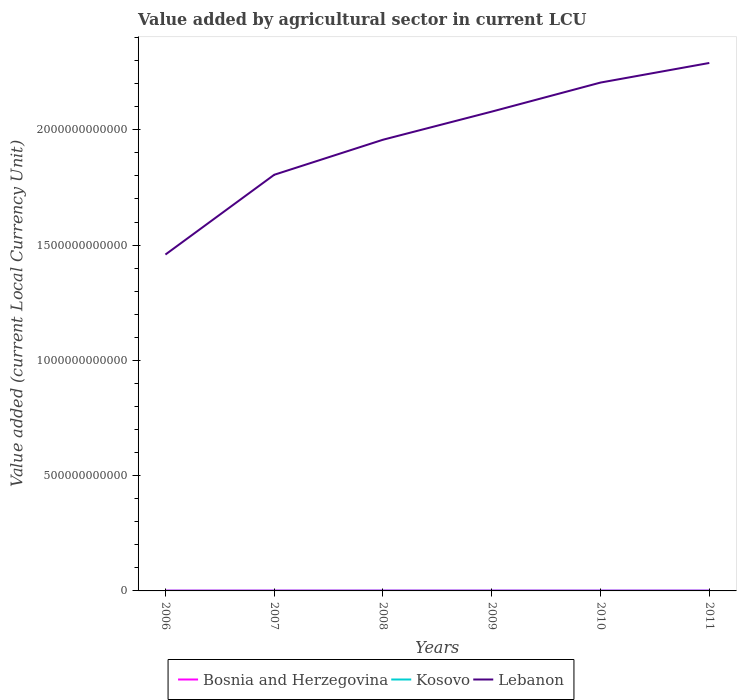Is the number of lines equal to the number of legend labels?
Keep it short and to the point. Yes. Across all years, what is the maximum value added by agricultural sector in Lebanon?
Give a very brief answer. 1.46e+12. What is the total value added by agricultural sector in Bosnia and Herzegovina in the graph?
Ensure brevity in your answer.  -1.02e+08. What is the difference between the highest and the second highest value added by agricultural sector in Lebanon?
Your answer should be very brief. 8.31e+11. What is the difference between the highest and the lowest value added by agricultural sector in Kosovo?
Offer a terse response. 4. How many years are there in the graph?
Your answer should be compact. 6. What is the difference between two consecutive major ticks on the Y-axis?
Offer a terse response. 5.00e+11. Are the values on the major ticks of Y-axis written in scientific E-notation?
Offer a very short reply. No. How many legend labels are there?
Give a very brief answer. 3. How are the legend labels stacked?
Your answer should be very brief. Horizontal. What is the title of the graph?
Give a very brief answer. Value added by agricultural sector in current LCU. Does "San Marino" appear as one of the legend labels in the graph?
Your answer should be compact. No. What is the label or title of the Y-axis?
Ensure brevity in your answer.  Value added (current Local Currency Unit). What is the Value added (current Local Currency Unit) in Bosnia and Herzegovina in 2006?
Offer a very short reply. 1.61e+09. What is the Value added (current Local Currency Unit) of Kosovo in 2006?
Offer a terse response. 3.72e+08. What is the Value added (current Local Currency Unit) of Lebanon in 2006?
Provide a short and direct response. 1.46e+12. What is the Value added (current Local Currency Unit) of Bosnia and Herzegovina in 2007?
Offer a very short reply. 1.73e+09. What is the Value added (current Local Currency Unit) of Kosovo in 2007?
Your response must be concise. 4.79e+08. What is the Value added (current Local Currency Unit) of Lebanon in 2007?
Your answer should be very brief. 1.80e+12. What is the Value added (current Local Currency Unit) in Bosnia and Herzegovina in 2008?
Provide a short and direct response. 1.83e+09. What is the Value added (current Local Currency Unit) in Kosovo in 2008?
Offer a very short reply. 5.74e+08. What is the Value added (current Local Currency Unit) of Lebanon in 2008?
Offer a terse response. 1.96e+12. What is the Value added (current Local Currency Unit) in Bosnia and Herzegovina in 2009?
Make the answer very short. 1.75e+09. What is the Value added (current Local Currency Unit) in Kosovo in 2009?
Provide a succinct answer. 5.75e+08. What is the Value added (current Local Currency Unit) of Lebanon in 2009?
Your response must be concise. 2.08e+12. What is the Value added (current Local Currency Unit) in Bosnia and Herzegovina in 2010?
Your answer should be very brief. 1.72e+09. What is the Value added (current Local Currency Unit) of Kosovo in 2010?
Make the answer very short. 5.99e+08. What is the Value added (current Local Currency Unit) in Lebanon in 2010?
Keep it short and to the point. 2.20e+12. What is the Value added (current Local Currency Unit) in Bosnia and Herzegovina in 2011?
Offer a terse response. 1.77e+09. What is the Value added (current Local Currency Unit) of Kosovo in 2011?
Offer a very short reply. 6.14e+08. What is the Value added (current Local Currency Unit) in Lebanon in 2011?
Give a very brief answer. 2.29e+12. Across all years, what is the maximum Value added (current Local Currency Unit) of Bosnia and Herzegovina?
Ensure brevity in your answer.  1.83e+09. Across all years, what is the maximum Value added (current Local Currency Unit) in Kosovo?
Provide a succinct answer. 6.14e+08. Across all years, what is the maximum Value added (current Local Currency Unit) of Lebanon?
Give a very brief answer. 2.29e+12. Across all years, what is the minimum Value added (current Local Currency Unit) in Bosnia and Herzegovina?
Your answer should be compact. 1.61e+09. Across all years, what is the minimum Value added (current Local Currency Unit) of Kosovo?
Your answer should be compact. 3.72e+08. Across all years, what is the minimum Value added (current Local Currency Unit) of Lebanon?
Your response must be concise. 1.46e+12. What is the total Value added (current Local Currency Unit) of Bosnia and Herzegovina in the graph?
Your answer should be compact. 1.04e+1. What is the total Value added (current Local Currency Unit) of Kosovo in the graph?
Keep it short and to the point. 3.21e+09. What is the total Value added (current Local Currency Unit) of Lebanon in the graph?
Your response must be concise. 1.18e+13. What is the difference between the Value added (current Local Currency Unit) of Bosnia and Herzegovina in 2006 and that in 2007?
Your answer should be compact. -1.23e+08. What is the difference between the Value added (current Local Currency Unit) of Kosovo in 2006 and that in 2007?
Offer a very short reply. -1.06e+08. What is the difference between the Value added (current Local Currency Unit) in Lebanon in 2006 and that in 2007?
Make the answer very short. -3.46e+11. What is the difference between the Value added (current Local Currency Unit) of Bosnia and Herzegovina in 2006 and that in 2008?
Your answer should be very brief. -2.25e+08. What is the difference between the Value added (current Local Currency Unit) in Kosovo in 2006 and that in 2008?
Provide a succinct answer. -2.02e+08. What is the difference between the Value added (current Local Currency Unit) of Lebanon in 2006 and that in 2008?
Provide a succinct answer. -4.98e+11. What is the difference between the Value added (current Local Currency Unit) in Bosnia and Herzegovina in 2006 and that in 2009?
Keep it short and to the point. -1.38e+08. What is the difference between the Value added (current Local Currency Unit) in Kosovo in 2006 and that in 2009?
Offer a very short reply. -2.03e+08. What is the difference between the Value added (current Local Currency Unit) in Lebanon in 2006 and that in 2009?
Provide a succinct answer. -6.20e+11. What is the difference between the Value added (current Local Currency Unit) in Bosnia and Herzegovina in 2006 and that in 2010?
Offer a terse response. -1.07e+08. What is the difference between the Value added (current Local Currency Unit) in Kosovo in 2006 and that in 2010?
Keep it short and to the point. -2.26e+08. What is the difference between the Value added (current Local Currency Unit) in Lebanon in 2006 and that in 2010?
Offer a terse response. -7.46e+11. What is the difference between the Value added (current Local Currency Unit) of Bosnia and Herzegovina in 2006 and that in 2011?
Provide a succinct answer. -1.58e+08. What is the difference between the Value added (current Local Currency Unit) of Kosovo in 2006 and that in 2011?
Provide a short and direct response. -2.42e+08. What is the difference between the Value added (current Local Currency Unit) of Lebanon in 2006 and that in 2011?
Provide a succinct answer. -8.31e+11. What is the difference between the Value added (current Local Currency Unit) of Bosnia and Herzegovina in 2007 and that in 2008?
Provide a short and direct response. -1.02e+08. What is the difference between the Value added (current Local Currency Unit) in Kosovo in 2007 and that in 2008?
Your answer should be compact. -9.56e+07. What is the difference between the Value added (current Local Currency Unit) in Lebanon in 2007 and that in 2008?
Offer a very short reply. -1.52e+11. What is the difference between the Value added (current Local Currency Unit) in Bosnia and Herzegovina in 2007 and that in 2009?
Offer a very short reply. -1.56e+07. What is the difference between the Value added (current Local Currency Unit) of Kosovo in 2007 and that in 2009?
Offer a very short reply. -9.64e+07. What is the difference between the Value added (current Local Currency Unit) in Lebanon in 2007 and that in 2009?
Your response must be concise. -2.74e+11. What is the difference between the Value added (current Local Currency Unit) of Bosnia and Herzegovina in 2007 and that in 2010?
Your answer should be compact. 1.55e+07. What is the difference between the Value added (current Local Currency Unit) of Kosovo in 2007 and that in 2010?
Your response must be concise. -1.20e+08. What is the difference between the Value added (current Local Currency Unit) in Lebanon in 2007 and that in 2010?
Make the answer very short. -4.00e+11. What is the difference between the Value added (current Local Currency Unit) of Bosnia and Herzegovina in 2007 and that in 2011?
Provide a short and direct response. -3.57e+07. What is the difference between the Value added (current Local Currency Unit) in Kosovo in 2007 and that in 2011?
Your answer should be compact. -1.36e+08. What is the difference between the Value added (current Local Currency Unit) in Lebanon in 2007 and that in 2011?
Give a very brief answer. -4.85e+11. What is the difference between the Value added (current Local Currency Unit) of Bosnia and Herzegovina in 2008 and that in 2009?
Your response must be concise. 8.65e+07. What is the difference between the Value added (current Local Currency Unit) in Kosovo in 2008 and that in 2009?
Provide a short and direct response. -8.00e+05. What is the difference between the Value added (current Local Currency Unit) in Lebanon in 2008 and that in 2009?
Offer a very short reply. -1.22e+11. What is the difference between the Value added (current Local Currency Unit) of Bosnia and Herzegovina in 2008 and that in 2010?
Make the answer very short. 1.18e+08. What is the difference between the Value added (current Local Currency Unit) in Kosovo in 2008 and that in 2010?
Give a very brief answer. -2.44e+07. What is the difference between the Value added (current Local Currency Unit) of Lebanon in 2008 and that in 2010?
Ensure brevity in your answer.  -2.48e+11. What is the difference between the Value added (current Local Currency Unit) in Bosnia and Herzegovina in 2008 and that in 2011?
Your answer should be compact. 6.64e+07. What is the difference between the Value added (current Local Currency Unit) of Kosovo in 2008 and that in 2011?
Keep it short and to the point. -3.99e+07. What is the difference between the Value added (current Local Currency Unit) in Lebanon in 2008 and that in 2011?
Give a very brief answer. -3.33e+11. What is the difference between the Value added (current Local Currency Unit) of Bosnia and Herzegovina in 2009 and that in 2010?
Offer a very short reply. 3.11e+07. What is the difference between the Value added (current Local Currency Unit) of Kosovo in 2009 and that in 2010?
Keep it short and to the point. -2.36e+07. What is the difference between the Value added (current Local Currency Unit) of Lebanon in 2009 and that in 2010?
Ensure brevity in your answer.  -1.26e+11. What is the difference between the Value added (current Local Currency Unit) of Bosnia and Herzegovina in 2009 and that in 2011?
Give a very brief answer. -2.01e+07. What is the difference between the Value added (current Local Currency Unit) in Kosovo in 2009 and that in 2011?
Offer a very short reply. -3.91e+07. What is the difference between the Value added (current Local Currency Unit) of Lebanon in 2009 and that in 2011?
Make the answer very short. -2.11e+11. What is the difference between the Value added (current Local Currency Unit) in Bosnia and Herzegovina in 2010 and that in 2011?
Ensure brevity in your answer.  -5.12e+07. What is the difference between the Value added (current Local Currency Unit) in Kosovo in 2010 and that in 2011?
Provide a short and direct response. -1.55e+07. What is the difference between the Value added (current Local Currency Unit) in Lebanon in 2010 and that in 2011?
Keep it short and to the point. -8.50e+1. What is the difference between the Value added (current Local Currency Unit) of Bosnia and Herzegovina in 2006 and the Value added (current Local Currency Unit) of Kosovo in 2007?
Provide a short and direct response. 1.13e+09. What is the difference between the Value added (current Local Currency Unit) of Bosnia and Herzegovina in 2006 and the Value added (current Local Currency Unit) of Lebanon in 2007?
Keep it short and to the point. -1.80e+12. What is the difference between the Value added (current Local Currency Unit) of Kosovo in 2006 and the Value added (current Local Currency Unit) of Lebanon in 2007?
Your response must be concise. -1.80e+12. What is the difference between the Value added (current Local Currency Unit) of Bosnia and Herzegovina in 2006 and the Value added (current Local Currency Unit) of Kosovo in 2008?
Make the answer very short. 1.04e+09. What is the difference between the Value added (current Local Currency Unit) in Bosnia and Herzegovina in 2006 and the Value added (current Local Currency Unit) in Lebanon in 2008?
Provide a succinct answer. -1.96e+12. What is the difference between the Value added (current Local Currency Unit) in Kosovo in 2006 and the Value added (current Local Currency Unit) in Lebanon in 2008?
Ensure brevity in your answer.  -1.96e+12. What is the difference between the Value added (current Local Currency Unit) in Bosnia and Herzegovina in 2006 and the Value added (current Local Currency Unit) in Kosovo in 2009?
Give a very brief answer. 1.03e+09. What is the difference between the Value added (current Local Currency Unit) of Bosnia and Herzegovina in 2006 and the Value added (current Local Currency Unit) of Lebanon in 2009?
Offer a terse response. -2.08e+12. What is the difference between the Value added (current Local Currency Unit) of Kosovo in 2006 and the Value added (current Local Currency Unit) of Lebanon in 2009?
Your answer should be compact. -2.08e+12. What is the difference between the Value added (current Local Currency Unit) in Bosnia and Herzegovina in 2006 and the Value added (current Local Currency Unit) in Kosovo in 2010?
Ensure brevity in your answer.  1.01e+09. What is the difference between the Value added (current Local Currency Unit) in Bosnia and Herzegovina in 2006 and the Value added (current Local Currency Unit) in Lebanon in 2010?
Make the answer very short. -2.20e+12. What is the difference between the Value added (current Local Currency Unit) of Kosovo in 2006 and the Value added (current Local Currency Unit) of Lebanon in 2010?
Your answer should be compact. -2.20e+12. What is the difference between the Value added (current Local Currency Unit) in Bosnia and Herzegovina in 2006 and the Value added (current Local Currency Unit) in Kosovo in 2011?
Your response must be concise. 9.96e+08. What is the difference between the Value added (current Local Currency Unit) in Bosnia and Herzegovina in 2006 and the Value added (current Local Currency Unit) in Lebanon in 2011?
Offer a terse response. -2.29e+12. What is the difference between the Value added (current Local Currency Unit) in Kosovo in 2006 and the Value added (current Local Currency Unit) in Lebanon in 2011?
Your answer should be very brief. -2.29e+12. What is the difference between the Value added (current Local Currency Unit) in Bosnia and Herzegovina in 2007 and the Value added (current Local Currency Unit) in Kosovo in 2008?
Your answer should be very brief. 1.16e+09. What is the difference between the Value added (current Local Currency Unit) of Bosnia and Herzegovina in 2007 and the Value added (current Local Currency Unit) of Lebanon in 2008?
Offer a terse response. -1.96e+12. What is the difference between the Value added (current Local Currency Unit) in Kosovo in 2007 and the Value added (current Local Currency Unit) in Lebanon in 2008?
Offer a terse response. -1.96e+12. What is the difference between the Value added (current Local Currency Unit) in Bosnia and Herzegovina in 2007 and the Value added (current Local Currency Unit) in Kosovo in 2009?
Offer a terse response. 1.16e+09. What is the difference between the Value added (current Local Currency Unit) in Bosnia and Herzegovina in 2007 and the Value added (current Local Currency Unit) in Lebanon in 2009?
Keep it short and to the point. -2.08e+12. What is the difference between the Value added (current Local Currency Unit) in Kosovo in 2007 and the Value added (current Local Currency Unit) in Lebanon in 2009?
Offer a terse response. -2.08e+12. What is the difference between the Value added (current Local Currency Unit) of Bosnia and Herzegovina in 2007 and the Value added (current Local Currency Unit) of Kosovo in 2010?
Your answer should be very brief. 1.13e+09. What is the difference between the Value added (current Local Currency Unit) of Bosnia and Herzegovina in 2007 and the Value added (current Local Currency Unit) of Lebanon in 2010?
Make the answer very short. -2.20e+12. What is the difference between the Value added (current Local Currency Unit) of Kosovo in 2007 and the Value added (current Local Currency Unit) of Lebanon in 2010?
Offer a very short reply. -2.20e+12. What is the difference between the Value added (current Local Currency Unit) of Bosnia and Herzegovina in 2007 and the Value added (current Local Currency Unit) of Kosovo in 2011?
Keep it short and to the point. 1.12e+09. What is the difference between the Value added (current Local Currency Unit) of Bosnia and Herzegovina in 2007 and the Value added (current Local Currency Unit) of Lebanon in 2011?
Give a very brief answer. -2.29e+12. What is the difference between the Value added (current Local Currency Unit) of Kosovo in 2007 and the Value added (current Local Currency Unit) of Lebanon in 2011?
Give a very brief answer. -2.29e+12. What is the difference between the Value added (current Local Currency Unit) in Bosnia and Herzegovina in 2008 and the Value added (current Local Currency Unit) in Kosovo in 2009?
Make the answer very short. 1.26e+09. What is the difference between the Value added (current Local Currency Unit) of Bosnia and Herzegovina in 2008 and the Value added (current Local Currency Unit) of Lebanon in 2009?
Make the answer very short. -2.08e+12. What is the difference between the Value added (current Local Currency Unit) in Kosovo in 2008 and the Value added (current Local Currency Unit) in Lebanon in 2009?
Give a very brief answer. -2.08e+12. What is the difference between the Value added (current Local Currency Unit) in Bosnia and Herzegovina in 2008 and the Value added (current Local Currency Unit) in Kosovo in 2010?
Offer a terse response. 1.24e+09. What is the difference between the Value added (current Local Currency Unit) of Bosnia and Herzegovina in 2008 and the Value added (current Local Currency Unit) of Lebanon in 2010?
Your answer should be very brief. -2.20e+12. What is the difference between the Value added (current Local Currency Unit) of Kosovo in 2008 and the Value added (current Local Currency Unit) of Lebanon in 2010?
Offer a very short reply. -2.20e+12. What is the difference between the Value added (current Local Currency Unit) in Bosnia and Herzegovina in 2008 and the Value added (current Local Currency Unit) in Kosovo in 2011?
Make the answer very short. 1.22e+09. What is the difference between the Value added (current Local Currency Unit) in Bosnia and Herzegovina in 2008 and the Value added (current Local Currency Unit) in Lebanon in 2011?
Provide a succinct answer. -2.29e+12. What is the difference between the Value added (current Local Currency Unit) of Kosovo in 2008 and the Value added (current Local Currency Unit) of Lebanon in 2011?
Ensure brevity in your answer.  -2.29e+12. What is the difference between the Value added (current Local Currency Unit) of Bosnia and Herzegovina in 2009 and the Value added (current Local Currency Unit) of Kosovo in 2010?
Your response must be concise. 1.15e+09. What is the difference between the Value added (current Local Currency Unit) in Bosnia and Herzegovina in 2009 and the Value added (current Local Currency Unit) in Lebanon in 2010?
Provide a short and direct response. -2.20e+12. What is the difference between the Value added (current Local Currency Unit) in Kosovo in 2009 and the Value added (current Local Currency Unit) in Lebanon in 2010?
Your answer should be very brief. -2.20e+12. What is the difference between the Value added (current Local Currency Unit) of Bosnia and Herzegovina in 2009 and the Value added (current Local Currency Unit) of Kosovo in 2011?
Your answer should be compact. 1.13e+09. What is the difference between the Value added (current Local Currency Unit) in Bosnia and Herzegovina in 2009 and the Value added (current Local Currency Unit) in Lebanon in 2011?
Your answer should be compact. -2.29e+12. What is the difference between the Value added (current Local Currency Unit) in Kosovo in 2009 and the Value added (current Local Currency Unit) in Lebanon in 2011?
Your answer should be very brief. -2.29e+12. What is the difference between the Value added (current Local Currency Unit) in Bosnia and Herzegovina in 2010 and the Value added (current Local Currency Unit) in Kosovo in 2011?
Make the answer very short. 1.10e+09. What is the difference between the Value added (current Local Currency Unit) in Bosnia and Herzegovina in 2010 and the Value added (current Local Currency Unit) in Lebanon in 2011?
Offer a terse response. -2.29e+12. What is the difference between the Value added (current Local Currency Unit) of Kosovo in 2010 and the Value added (current Local Currency Unit) of Lebanon in 2011?
Offer a very short reply. -2.29e+12. What is the average Value added (current Local Currency Unit) of Bosnia and Herzegovina per year?
Your response must be concise. 1.74e+09. What is the average Value added (current Local Currency Unit) of Kosovo per year?
Offer a very short reply. 5.36e+08. What is the average Value added (current Local Currency Unit) of Lebanon per year?
Give a very brief answer. 1.97e+12. In the year 2006, what is the difference between the Value added (current Local Currency Unit) in Bosnia and Herzegovina and Value added (current Local Currency Unit) in Kosovo?
Your response must be concise. 1.24e+09. In the year 2006, what is the difference between the Value added (current Local Currency Unit) of Bosnia and Herzegovina and Value added (current Local Currency Unit) of Lebanon?
Give a very brief answer. -1.46e+12. In the year 2006, what is the difference between the Value added (current Local Currency Unit) of Kosovo and Value added (current Local Currency Unit) of Lebanon?
Your answer should be compact. -1.46e+12. In the year 2007, what is the difference between the Value added (current Local Currency Unit) in Bosnia and Herzegovina and Value added (current Local Currency Unit) in Kosovo?
Provide a succinct answer. 1.25e+09. In the year 2007, what is the difference between the Value added (current Local Currency Unit) of Bosnia and Herzegovina and Value added (current Local Currency Unit) of Lebanon?
Make the answer very short. -1.80e+12. In the year 2007, what is the difference between the Value added (current Local Currency Unit) in Kosovo and Value added (current Local Currency Unit) in Lebanon?
Your response must be concise. -1.80e+12. In the year 2008, what is the difference between the Value added (current Local Currency Unit) of Bosnia and Herzegovina and Value added (current Local Currency Unit) of Kosovo?
Give a very brief answer. 1.26e+09. In the year 2008, what is the difference between the Value added (current Local Currency Unit) in Bosnia and Herzegovina and Value added (current Local Currency Unit) in Lebanon?
Provide a short and direct response. -1.96e+12. In the year 2008, what is the difference between the Value added (current Local Currency Unit) in Kosovo and Value added (current Local Currency Unit) in Lebanon?
Your answer should be very brief. -1.96e+12. In the year 2009, what is the difference between the Value added (current Local Currency Unit) of Bosnia and Herzegovina and Value added (current Local Currency Unit) of Kosovo?
Ensure brevity in your answer.  1.17e+09. In the year 2009, what is the difference between the Value added (current Local Currency Unit) in Bosnia and Herzegovina and Value added (current Local Currency Unit) in Lebanon?
Ensure brevity in your answer.  -2.08e+12. In the year 2009, what is the difference between the Value added (current Local Currency Unit) in Kosovo and Value added (current Local Currency Unit) in Lebanon?
Ensure brevity in your answer.  -2.08e+12. In the year 2010, what is the difference between the Value added (current Local Currency Unit) of Bosnia and Herzegovina and Value added (current Local Currency Unit) of Kosovo?
Offer a very short reply. 1.12e+09. In the year 2010, what is the difference between the Value added (current Local Currency Unit) in Bosnia and Herzegovina and Value added (current Local Currency Unit) in Lebanon?
Offer a terse response. -2.20e+12. In the year 2010, what is the difference between the Value added (current Local Currency Unit) of Kosovo and Value added (current Local Currency Unit) of Lebanon?
Make the answer very short. -2.20e+12. In the year 2011, what is the difference between the Value added (current Local Currency Unit) in Bosnia and Herzegovina and Value added (current Local Currency Unit) in Kosovo?
Make the answer very short. 1.15e+09. In the year 2011, what is the difference between the Value added (current Local Currency Unit) of Bosnia and Herzegovina and Value added (current Local Currency Unit) of Lebanon?
Give a very brief answer. -2.29e+12. In the year 2011, what is the difference between the Value added (current Local Currency Unit) of Kosovo and Value added (current Local Currency Unit) of Lebanon?
Give a very brief answer. -2.29e+12. What is the ratio of the Value added (current Local Currency Unit) in Bosnia and Herzegovina in 2006 to that in 2007?
Provide a succinct answer. 0.93. What is the ratio of the Value added (current Local Currency Unit) of Lebanon in 2006 to that in 2007?
Make the answer very short. 0.81. What is the ratio of the Value added (current Local Currency Unit) in Bosnia and Herzegovina in 2006 to that in 2008?
Ensure brevity in your answer.  0.88. What is the ratio of the Value added (current Local Currency Unit) in Kosovo in 2006 to that in 2008?
Your response must be concise. 0.65. What is the ratio of the Value added (current Local Currency Unit) of Lebanon in 2006 to that in 2008?
Keep it short and to the point. 0.75. What is the ratio of the Value added (current Local Currency Unit) of Bosnia and Herzegovina in 2006 to that in 2009?
Provide a short and direct response. 0.92. What is the ratio of the Value added (current Local Currency Unit) of Kosovo in 2006 to that in 2009?
Give a very brief answer. 0.65. What is the ratio of the Value added (current Local Currency Unit) of Lebanon in 2006 to that in 2009?
Your answer should be compact. 0.7. What is the ratio of the Value added (current Local Currency Unit) of Bosnia and Herzegovina in 2006 to that in 2010?
Keep it short and to the point. 0.94. What is the ratio of the Value added (current Local Currency Unit) in Kosovo in 2006 to that in 2010?
Provide a succinct answer. 0.62. What is the ratio of the Value added (current Local Currency Unit) of Lebanon in 2006 to that in 2010?
Your response must be concise. 0.66. What is the ratio of the Value added (current Local Currency Unit) of Bosnia and Herzegovina in 2006 to that in 2011?
Make the answer very short. 0.91. What is the ratio of the Value added (current Local Currency Unit) in Kosovo in 2006 to that in 2011?
Give a very brief answer. 0.61. What is the ratio of the Value added (current Local Currency Unit) of Lebanon in 2006 to that in 2011?
Provide a short and direct response. 0.64. What is the ratio of the Value added (current Local Currency Unit) in Kosovo in 2007 to that in 2008?
Make the answer very short. 0.83. What is the ratio of the Value added (current Local Currency Unit) of Lebanon in 2007 to that in 2008?
Your answer should be very brief. 0.92. What is the ratio of the Value added (current Local Currency Unit) of Bosnia and Herzegovina in 2007 to that in 2009?
Make the answer very short. 0.99. What is the ratio of the Value added (current Local Currency Unit) of Kosovo in 2007 to that in 2009?
Your answer should be compact. 0.83. What is the ratio of the Value added (current Local Currency Unit) of Lebanon in 2007 to that in 2009?
Your answer should be compact. 0.87. What is the ratio of the Value added (current Local Currency Unit) in Bosnia and Herzegovina in 2007 to that in 2010?
Ensure brevity in your answer.  1.01. What is the ratio of the Value added (current Local Currency Unit) of Kosovo in 2007 to that in 2010?
Your answer should be compact. 0.8. What is the ratio of the Value added (current Local Currency Unit) of Lebanon in 2007 to that in 2010?
Keep it short and to the point. 0.82. What is the ratio of the Value added (current Local Currency Unit) in Bosnia and Herzegovina in 2007 to that in 2011?
Give a very brief answer. 0.98. What is the ratio of the Value added (current Local Currency Unit) in Kosovo in 2007 to that in 2011?
Give a very brief answer. 0.78. What is the ratio of the Value added (current Local Currency Unit) in Lebanon in 2007 to that in 2011?
Give a very brief answer. 0.79. What is the ratio of the Value added (current Local Currency Unit) in Bosnia and Herzegovina in 2008 to that in 2009?
Offer a very short reply. 1.05. What is the ratio of the Value added (current Local Currency Unit) in Lebanon in 2008 to that in 2009?
Offer a very short reply. 0.94. What is the ratio of the Value added (current Local Currency Unit) in Bosnia and Herzegovina in 2008 to that in 2010?
Your answer should be very brief. 1.07. What is the ratio of the Value added (current Local Currency Unit) in Kosovo in 2008 to that in 2010?
Provide a succinct answer. 0.96. What is the ratio of the Value added (current Local Currency Unit) of Lebanon in 2008 to that in 2010?
Your answer should be very brief. 0.89. What is the ratio of the Value added (current Local Currency Unit) of Bosnia and Herzegovina in 2008 to that in 2011?
Your answer should be very brief. 1.04. What is the ratio of the Value added (current Local Currency Unit) of Kosovo in 2008 to that in 2011?
Provide a short and direct response. 0.94. What is the ratio of the Value added (current Local Currency Unit) of Lebanon in 2008 to that in 2011?
Offer a terse response. 0.85. What is the ratio of the Value added (current Local Currency Unit) in Bosnia and Herzegovina in 2009 to that in 2010?
Your answer should be compact. 1.02. What is the ratio of the Value added (current Local Currency Unit) of Kosovo in 2009 to that in 2010?
Make the answer very short. 0.96. What is the ratio of the Value added (current Local Currency Unit) in Lebanon in 2009 to that in 2010?
Offer a terse response. 0.94. What is the ratio of the Value added (current Local Currency Unit) of Bosnia and Herzegovina in 2009 to that in 2011?
Offer a terse response. 0.99. What is the ratio of the Value added (current Local Currency Unit) of Kosovo in 2009 to that in 2011?
Provide a succinct answer. 0.94. What is the ratio of the Value added (current Local Currency Unit) in Lebanon in 2009 to that in 2011?
Make the answer very short. 0.91. What is the ratio of the Value added (current Local Currency Unit) of Bosnia and Herzegovina in 2010 to that in 2011?
Offer a very short reply. 0.97. What is the ratio of the Value added (current Local Currency Unit) of Kosovo in 2010 to that in 2011?
Make the answer very short. 0.97. What is the ratio of the Value added (current Local Currency Unit) of Lebanon in 2010 to that in 2011?
Keep it short and to the point. 0.96. What is the difference between the highest and the second highest Value added (current Local Currency Unit) in Bosnia and Herzegovina?
Your answer should be very brief. 6.64e+07. What is the difference between the highest and the second highest Value added (current Local Currency Unit) in Kosovo?
Offer a terse response. 1.55e+07. What is the difference between the highest and the second highest Value added (current Local Currency Unit) in Lebanon?
Provide a succinct answer. 8.50e+1. What is the difference between the highest and the lowest Value added (current Local Currency Unit) of Bosnia and Herzegovina?
Provide a succinct answer. 2.25e+08. What is the difference between the highest and the lowest Value added (current Local Currency Unit) of Kosovo?
Make the answer very short. 2.42e+08. What is the difference between the highest and the lowest Value added (current Local Currency Unit) of Lebanon?
Your answer should be very brief. 8.31e+11. 